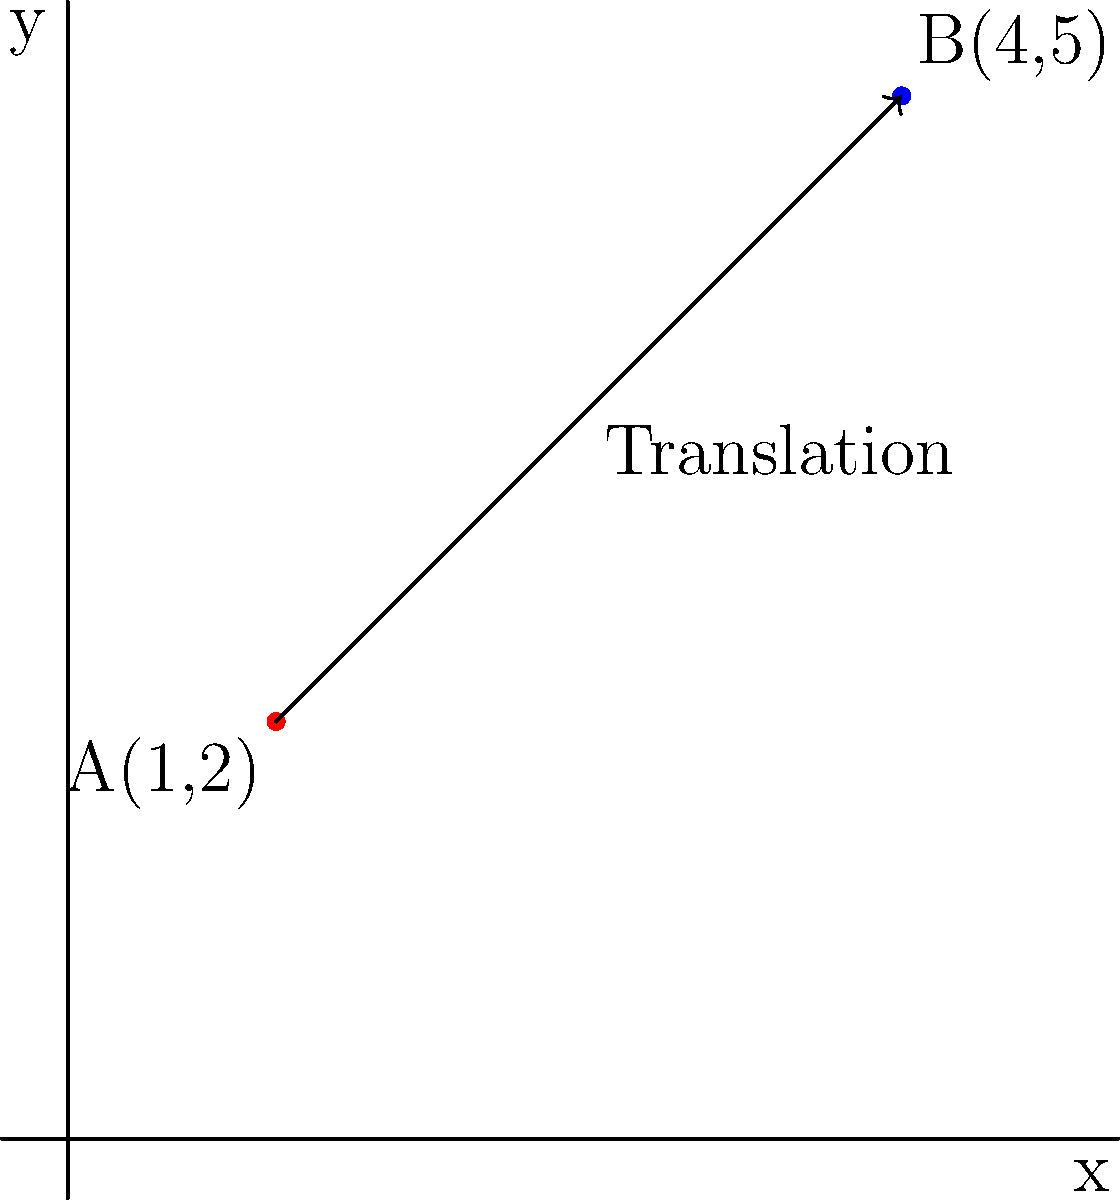A traditional Balinese offering basket (canang sari) is initially placed at point A(1,2) on a coordinate plane representing your beachfront property. You decide to move it to a new location B(4,5) to better showcase it to visitors. What is the translation vector that describes this movement? To find the translation vector, we need to follow these steps:

1) The translation vector is the difference between the final position and the initial position.

2) The initial position (point A) is (1,2).
   The final position (point B) is (4,5).

3) To calculate the translation vector:
   $$(x_2 - x_1, y_2 - y_1) = (4-1, 5-2)$$

4) Simplify:
   $$(3, 3)$$

Therefore, the translation vector that moves the canang sari from point A to point B is $\langle 3, 3 \rangle$.
Answer: $\langle 3, 3 \rangle$ 